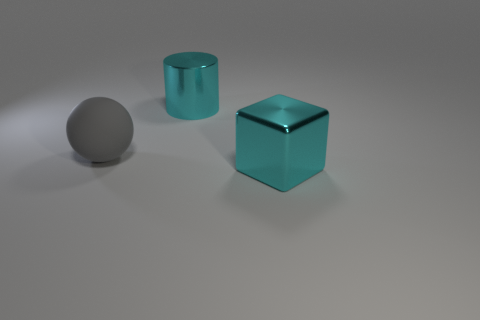Add 1 yellow metallic cubes. How many objects exist? 4 Subtract all gray spheres. Subtract all large cubes. How many objects are left? 1 Add 1 gray things. How many gray things are left? 2 Add 1 cylinders. How many cylinders exist? 2 Subtract 0 gray blocks. How many objects are left? 3 Subtract all cubes. How many objects are left? 2 